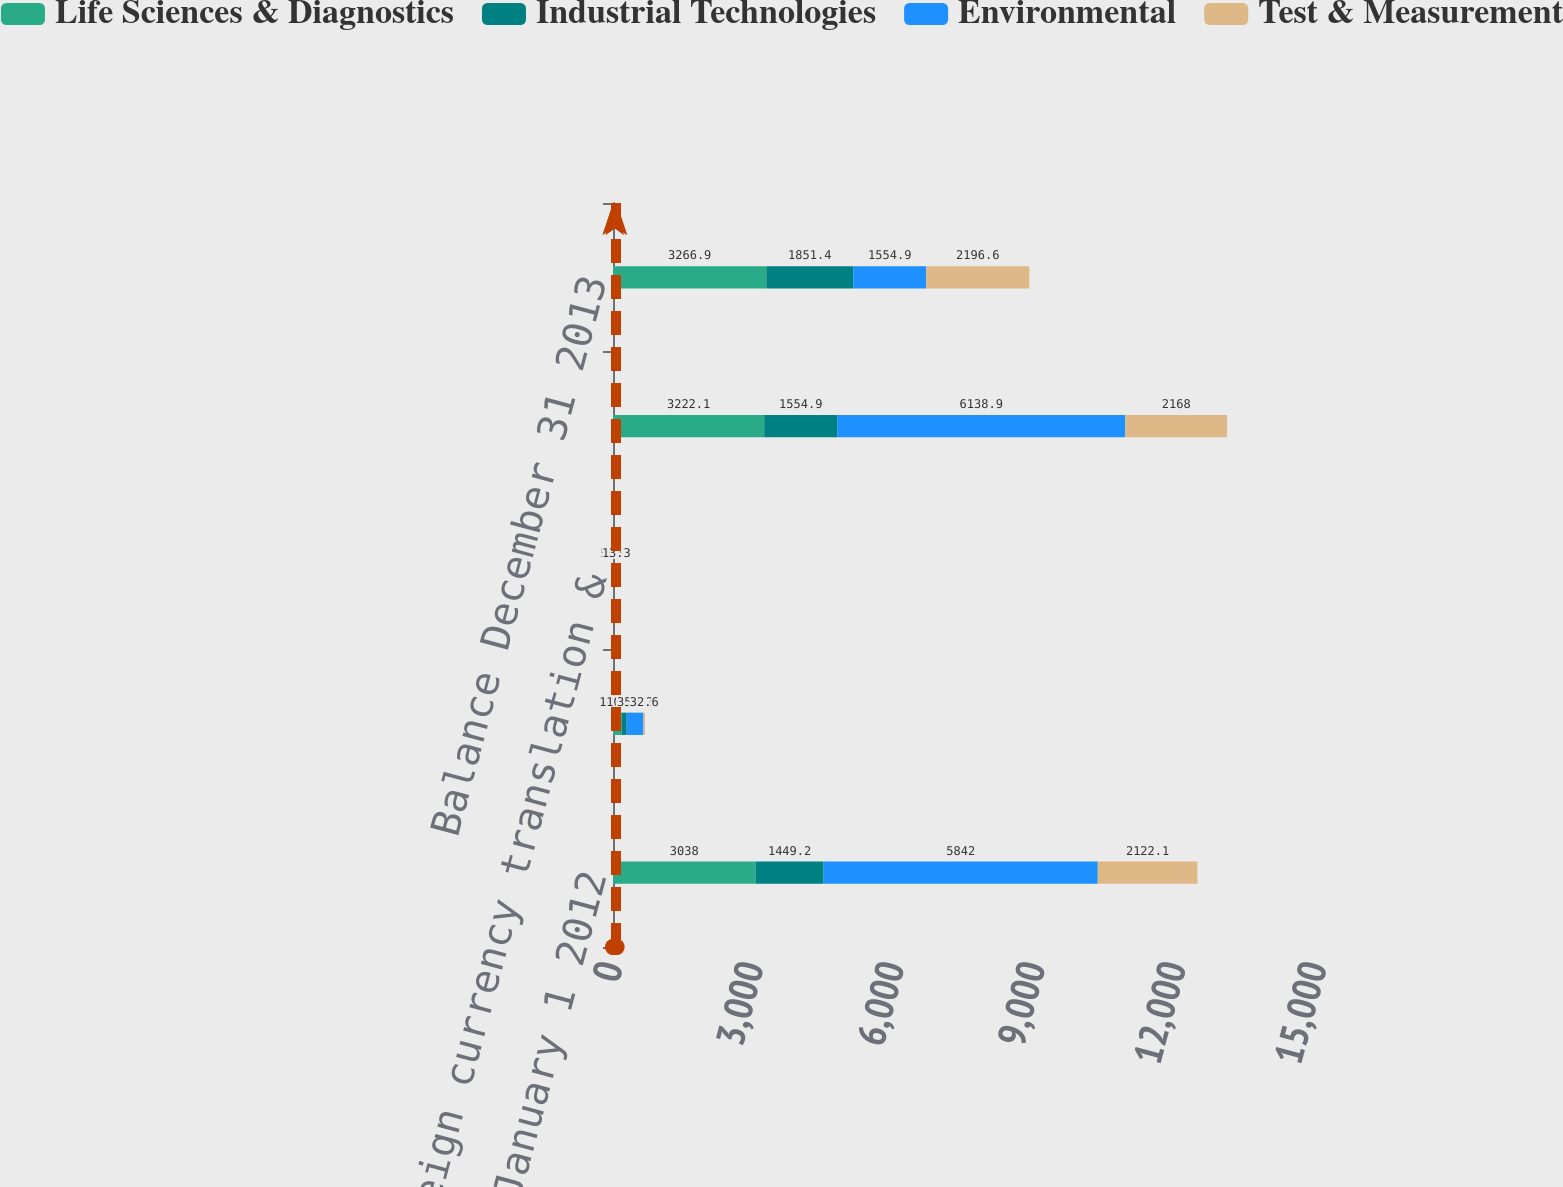<chart> <loc_0><loc_0><loc_500><loc_500><stacked_bar_chart><ecel><fcel>Balance January 1 2012<fcel>Attributable to 2012<fcel>Foreign currency translation &<fcel>Balance December 31 2012<fcel>Balance December 31 2013<nl><fcel>Life Sciences & Diagnostics<fcel>3038<fcel>187.9<fcel>3.8<fcel>3222.1<fcel>3266.9<nl><fcel>Industrial Technologies<fcel>1449.2<fcel>104.6<fcel>1.1<fcel>1554.9<fcel>1851.4<nl><fcel>Environmental<fcel>5842<fcel>356.2<fcel>59.3<fcel>6138.9<fcel>1554.9<nl><fcel>Test & Measurement<fcel>2122.1<fcel>32.6<fcel>13.3<fcel>2168<fcel>2196.6<nl></chart> 